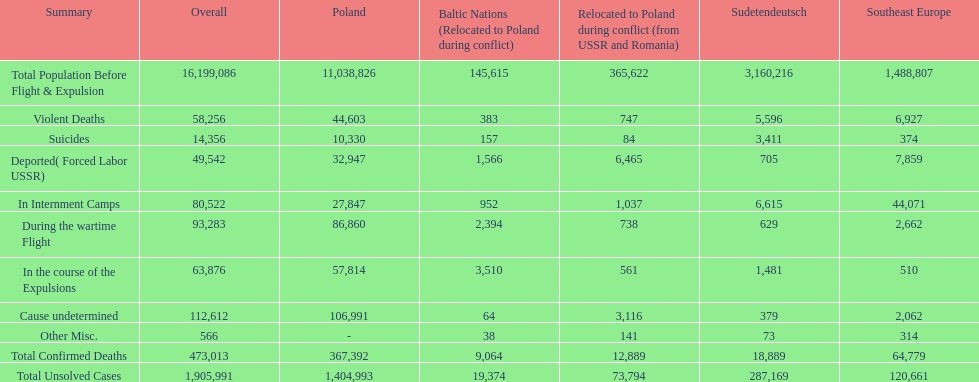Were there more cause undetermined or miscellaneous deaths in the baltic states? Cause undetermined. 